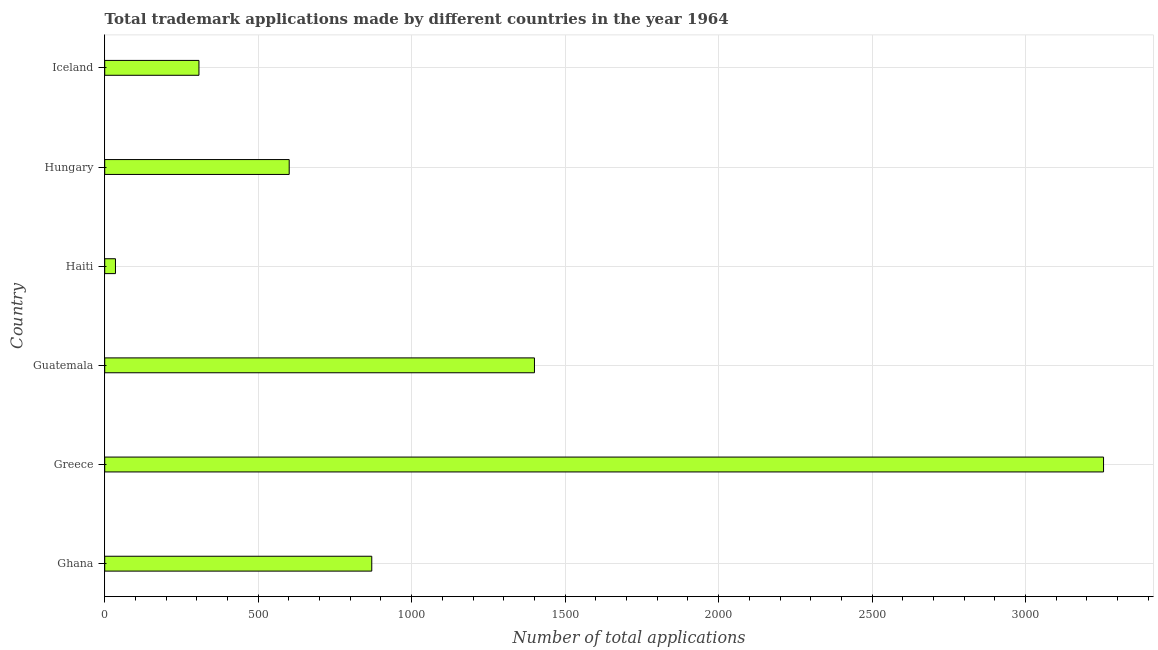Does the graph contain any zero values?
Offer a very short reply. No. Does the graph contain grids?
Keep it short and to the point. Yes. What is the title of the graph?
Your answer should be very brief. Total trademark applications made by different countries in the year 1964. What is the label or title of the X-axis?
Offer a terse response. Number of total applications. What is the number of trademark applications in Ghana?
Provide a succinct answer. 870. Across all countries, what is the maximum number of trademark applications?
Your answer should be compact. 3254. Across all countries, what is the minimum number of trademark applications?
Provide a short and direct response. 35. In which country was the number of trademark applications minimum?
Your response must be concise. Haiti. What is the sum of the number of trademark applications?
Your answer should be compact. 6467. What is the difference between the number of trademark applications in Greece and Haiti?
Keep it short and to the point. 3219. What is the average number of trademark applications per country?
Provide a succinct answer. 1077. What is the median number of trademark applications?
Your answer should be compact. 735.5. In how many countries, is the number of trademark applications greater than 2600 ?
Provide a succinct answer. 1. What is the ratio of the number of trademark applications in Guatemala to that in Hungary?
Ensure brevity in your answer.  2.33. Is the difference between the number of trademark applications in Greece and Haiti greater than the difference between any two countries?
Offer a terse response. Yes. What is the difference between the highest and the second highest number of trademark applications?
Provide a short and direct response. 1854. What is the difference between the highest and the lowest number of trademark applications?
Offer a very short reply. 3219. In how many countries, is the number of trademark applications greater than the average number of trademark applications taken over all countries?
Provide a succinct answer. 2. Are all the bars in the graph horizontal?
Give a very brief answer. Yes. How many countries are there in the graph?
Keep it short and to the point. 6. What is the Number of total applications in Ghana?
Ensure brevity in your answer.  870. What is the Number of total applications in Greece?
Your answer should be compact. 3254. What is the Number of total applications of Guatemala?
Your answer should be very brief. 1400. What is the Number of total applications of Haiti?
Your answer should be compact. 35. What is the Number of total applications in Hungary?
Ensure brevity in your answer.  601. What is the Number of total applications of Iceland?
Give a very brief answer. 307. What is the difference between the Number of total applications in Ghana and Greece?
Offer a terse response. -2384. What is the difference between the Number of total applications in Ghana and Guatemala?
Offer a terse response. -530. What is the difference between the Number of total applications in Ghana and Haiti?
Give a very brief answer. 835. What is the difference between the Number of total applications in Ghana and Hungary?
Provide a succinct answer. 269. What is the difference between the Number of total applications in Ghana and Iceland?
Keep it short and to the point. 563. What is the difference between the Number of total applications in Greece and Guatemala?
Make the answer very short. 1854. What is the difference between the Number of total applications in Greece and Haiti?
Your answer should be very brief. 3219. What is the difference between the Number of total applications in Greece and Hungary?
Provide a short and direct response. 2653. What is the difference between the Number of total applications in Greece and Iceland?
Keep it short and to the point. 2947. What is the difference between the Number of total applications in Guatemala and Haiti?
Make the answer very short. 1365. What is the difference between the Number of total applications in Guatemala and Hungary?
Your response must be concise. 799. What is the difference between the Number of total applications in Guatemala and Iceland?
Offer a terse response. 1093. What is the difference between the Number of total applications in Haiti and Hungary?
Your response must be concise. -566. What is the difference between the Number of total applications in Haiti and Iceland?
Provide a short and direct response. -272. What is the difference between the Number of total applications in Hungary and Iceland?
Keep it short and to the point. 294. What is the ratio of the Number of total applications in Ghana to that in Greece?
Keep it short and to the point. 0.27. What is the ratio of the Number of total applications in Ghana to that in Guatemala?
Make the answer very short. 0.62. What is the ratio of the Number of total applications in Ghana to that in Haiti?
Your answer should be compact. 24.86. What is the ratio of the Number of total applications in Ghana to that in Hungary?
Your answer should be very brief. 1.45. What is the ratio of the Number of total applications in Ghana to that in Iceland?
Offer a terse response. 2.83. What is the ratio of the Number of total applications in Greece to that in Guatemala?
Your answer should be very brief. 2.32. What is the ratio of the Number of total applications in Greece to that in Haiti?
Offer a terse response. 92.97. What is the ratio of the Number of total applications in Greece to that in Hungary?
Your answer should be very brief. 5.41. What is the ratio of the Number of total applications in Greece to that in Iceland?
Make the answer very short. 10.6. What is the ratio of the Number of total applications in Guatemala to that in Haiti?
Provide a short and direct response. 40. What is the ratio of the Number of total applications in Guatemala to that in Hungary?
Provide a succinct answer. 2.33. What is the ratio of the Number of total applications in Guatemala to that in Iceland?
Provide a short and direct response. 4.56. What is the ratio of the Number of total applications in Haiti to that in Hungary?
Your response must be concise. 0.06. What is the ratio of the Number of total applications in Haiti to that in Iceland?
Your response must be concise. 0.11. What is the ratio of the Number of total applications in Hungary to that in Iceland?
Make the answer very short. 1.96. 